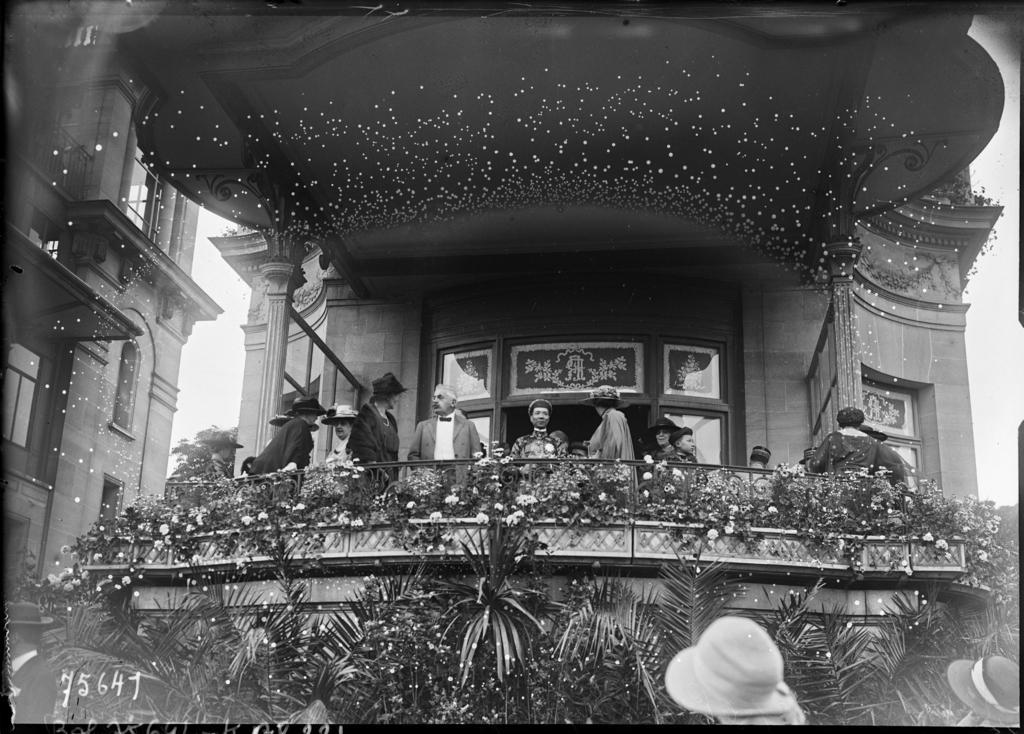Describe this image in one or two sentences. In the picture we can see a palace which is decorated with flowers, plants to the railing and some people in the house and to the roof, we can see decorated lights and besides we can see another building with a glass window. 